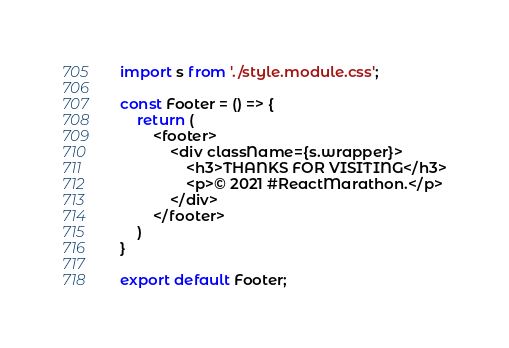Convert code to text. <code><loc_0><loc_0><loc_500><loc_500><_JavaScript_>import s from './style.module.css';

const Footer = () => {
    return (
        <footer>
            <div className={s.wrapper}>
                <h3>THANKS FOR VISITING</h3>
                <p>© 2021 #ReactMarathon.</p>
            </div>
        </footer>
    )
}

export default Footer;
</code> 